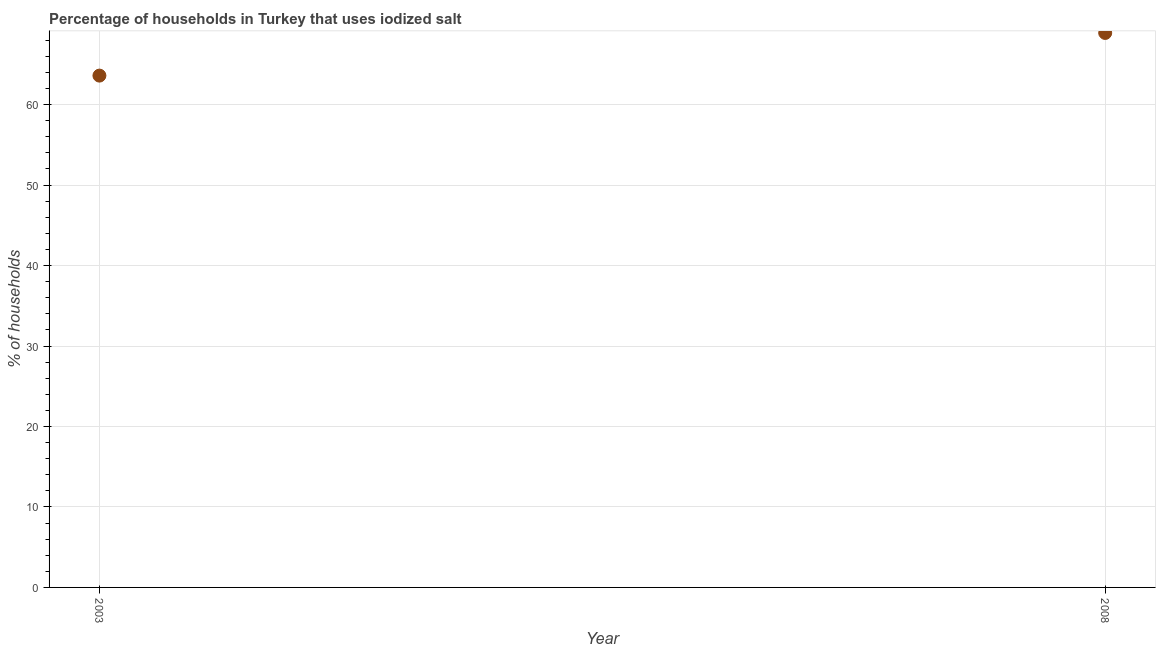What is the percentage of households where iodized salt is consumed in 2003?
Ensure brevity in your answer.  63.6. Across all years, what is the maximum percentage of households where iodized salt is consumed?
Make the answer very short. 68.9. Across all years, what is the minimum percentage of households where iodized salt is consumed?
Make the answer very short. 63.6. In which year was the percentage of households where iodized salt is consumed maximum?
Keep it short and to the point. 2008. What is the sum of the percentage of households where iodized salt is consumed?
Offer a terse response. 132.5. What is the difference between the percentage of households where iodized salt is consumed in 2003 and 2008?
Provide a short and direct response. -5.3. What is the average percentage of households where iodized salt is consumed per year?
Make the answer very short. 66.25. What is the median percentage of households where iodized salt is consumed?
Keep it short and to the point. 66.25. In how many years, is the percentage of households where iodized salt is consumed greater than 54 %?
Provide a succinct answer. 2. Do a majority of the years between 2003 and 2008 (inclusive) have percentage of households where iodized salt is consumed greater than 66 %?
Make the answer very short. No. What is the ratio of the percentage of households where iodized salt is consumed in 2003 to that in 2008?
Provide a short and direct response. 0.92. Is the percentage of households where iodized salt is consumed in 2003 less than that in 2008?
Offer a terse response. Yes. In how many years, is the percentage of households where iodized salt is consumed greater than the average percentage of households where iodized salt is consumed taken over all years?
Offer a very short reply. 1. Does the percentage of households where iodized salt is consumed monotonically increase over the years?
Offer a very short reply. Yes. How many dotlines are there?
Keep it short and to the point. 1. How many years are there in the graph?
Your response must be concise. 2. What is the difference between two consecutive major ticks on the Y-axis?
Make the answer very short. 10. What is the title of the graph?
Give a very brief answer. Percentage of households in Turkey that uses iodized salt. What is the label or title of the Y-axis?
Provide a succinct answer. % of households. What is the % of households in 2003?
Make the answer very short. 63.6. What is the % of households in 2008?
Give a very brief answer. 68.9. What is the ratio of the % of households in 2003 to that in 2008?
Offer a terse response. 0.92. 